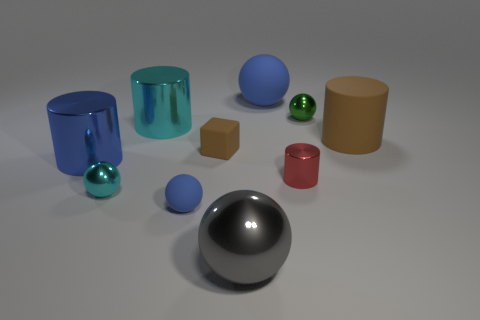There is a metal cylinder that is in front of the blue metal cylinder; is it the same color as the small matte block? The metal cylinder in front of the blue cylinder is not the same color as the small matte block. The cylinder has a reflective chrome finish, which mirrors the environment, while the small block has a matte brown color with a uniform appearance. 